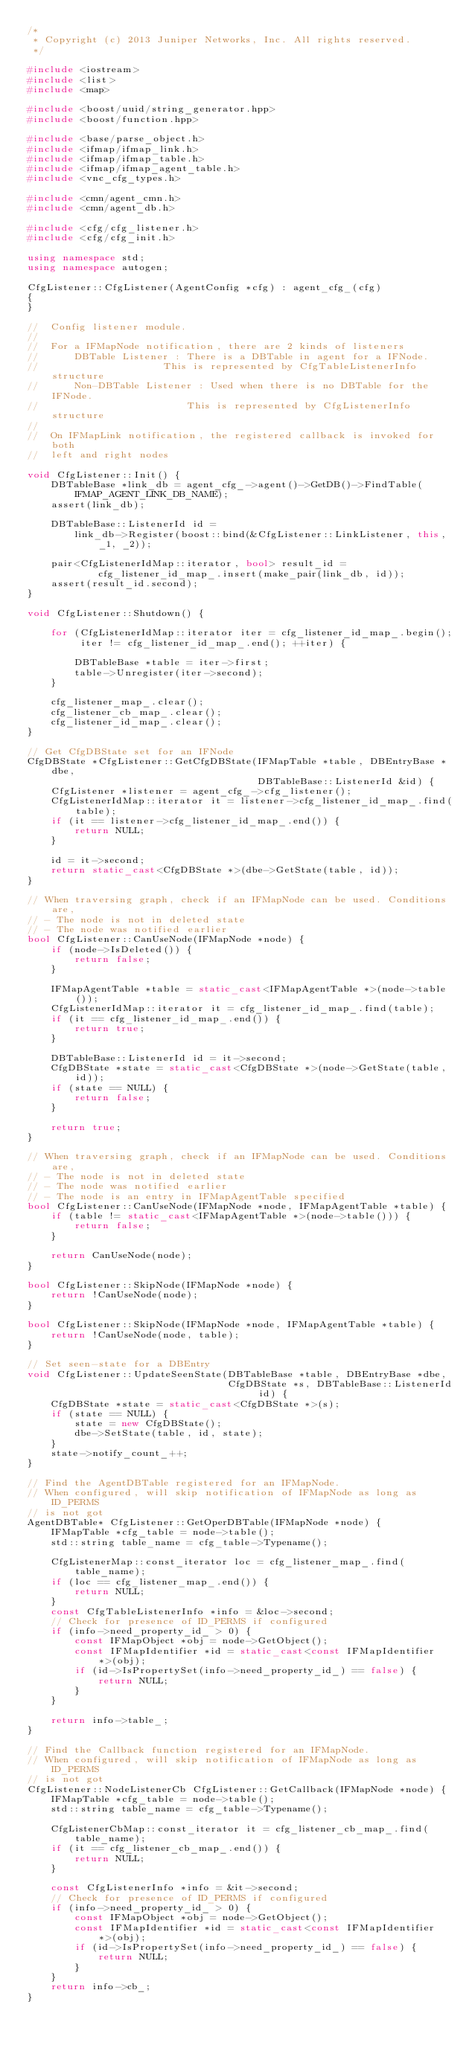Convert code to text. <code><loc_0><loc_0><loc_500><loc_500><_C++_>/*
 * Copyright (c) 2013 Juniper Networks, Inc. All rights reserved.
 */

#include <iostream>
#include <list>
#include <map>

#include <boost/uuid/string_generator.hpp>
#include <boost/function.hpp>

#include <base/parse_object.h>
#include <ifmap/ifmap_link.h>
#include <ifmap/ifmap_table.h>
#include <ifmap/ifmap_agent_table.h>
#include <vnc_cfg_types.h>

#include <cmn/agent_cmn.h>
#include <cmn/agent_db.h>

#include <cfg/cfg_listener.h>
#include <cfg/cfg_init.h>

using namespace std;
using namespace autogen;

CfgListener::CfgListener(AgentConfig *cfg) : agent_cfg_(cfg) 
{ 
}

//  Config listener module. 
//
//  For a IFMapNode notification, there are 2 kinds of listeners
//      DBTable Listener : There is a DBTable in agent for a IFNode. 
//                     This is represented by CfgTableListenerInfo structure
//      Non-DBTable Listener : Used when there is no DBTable for the IFNode.
//                         This is represented by CfgListenerInfo structure
//
//  On IFMapLink notification, the registered callback is invoked for both
//  left and right nodes

void CfgListener::Init() {
    DBTableBase *link_db = agent_cfg_->agent()->GetDB()->FindTable(IFMAP_AGENT_LINK_DB_NAME);
    assert(link_db);

    DBTableBase::ListenerId id = 
        link_db->Register(boost::bind(&CfgListener::LinkListener, this, _1, _2));

    pair<CfgListenerIdMap::iterator, bool> result_id =
            cfg_listener_id_map_.insert(make_pair(link_db, id));
    assert(result_id.second);
}

void CfgListener::Shutdown() {

    for (CfgListenerIdMap::iterator iter = cfg_listener_id_map_.begin();
         iter != cfg_listener_id_map_.end(); ++iter) {

        DBTableBase *table = iter->first;
        table->Unregister(iter->second);
    }

    cfg_listener_map_.clear();
    cfg_listener_cb_map_.clear();
    cfg_listener_id_map_.clear();
}

// Get CfgDBState set for an IFNode
CfgDBState *CfgListener::GetCfgDBState(IFMapTable *table, DBEntryBase *dbe,
                                       DBTableBase::ListenerId &id) {
    CfgListener *listener = agent_cfg_->cfg_listener();
    CfgListenerIdMap::iterator it = listener->cfg_listener_id_map_.find(table);
    if (it == listener->cfg_listener_id_map_.end()) {
        return NULL;
    }

    id = it->second;
    return static_cast<CfgDBState *>(dbe->GetState(table, id));
}

// When traversing graph, check if an IFMapNode can be used. Conditions are,
// - The node is not in deleted state
// - The node was notified earlier
bool CfgListener::CanUseNode(IFMapNode *node) {
    if (node->IsDeleted()) {
        return false;
    }

    IFMapAgentTable *table = static_cast<IFMapAgentTable *>(node->table());
    CfgListenerIdMap::iterator it = cfg_listener_id_map_.find(table);
    if (it == cfg_listener_id_map_.end()) {
        return true;
    }

    DBTableBase::ListenerId id = it->second;
    CfgDBState *state = static_cast<CfgDBState *>(node->GetState(table, id));
    if (state == NULL) {
        return false;
    }

    return true;
}

// When traversing graph, check if an IFMapNode can be used. Conditions are,
// - The node is not in deleted state
// - The node was notified earlier
// - The node is an entry in IFMapAgentTable specified
bool CfgListener::CanUseNode(IFMapNode *node, IFMapAgentTable *table) {
    if (table != static_cast<IFMapAgentTable *>(node->table())) {
        return false;
    }

    return CanUseNode(node);
}

bool CfgListener::SkipNode(IFMapNode *node) {
    return !CanUseNode(node);
}

bool CfgListener::SkipNode(IFMapNode *node, IFMapAgentTable *table) {
    return !CanUseNode(node, table);
}

// Set seen-state for a DBEntry
void CfgListener::UpdateSeenState(DBTableBase *table, DBEntryBase *dbe,
                                  CfgDBState *s, DBTableBase::ListenerId id) {
    CfgDBState *state = static_cast<CfgDBState *>(s);
    if (state == NULL) {
        state = new CfgDBState();
        dbe->SetState(table, id, state);
    }
    state->notify_count_++;
}

// Find the AgentDBTable registered for an IFMapNode.
// When configured, will skip notification of IFMapNode as long as ID_PERMS
// is not got
AgentDBTable* CfgListener::GetOperDBTable(IFMapNode *node) {
    IFMapTable *cfg_table = node->table();
    std::string table_name = cfg_table->Typename();

    CfgListenerMap::const_iterator loc = cfg_listener_map_.find(table_name);
    if (loc == cfg_listener_map_.end()) {
        return NULL;
    }
    const CfgTableListenerInfo *info = &loc->second;
    // Check for presence of ID_PERMS if configured
    if (info->need_property_id_ > 0) {
        const IFMapObject *obj = node->GetObject();
        const IFMapIdentifier *id = static_cast<const IFMapIdentifier *>(obj);
        if (id->IsPropertySet(info->need_property_id_) == false) {
            return NULL;
        }
    }

    return info->table_;
}

// Find the Callback function registered for an IFMapNode.
// When configured, will skip notification of IFMapNode as long as ID_PERMS
// is not got
CfgListener::NodeListenerCb CfgListener::GetCallback(IFMapNode *node) {
    IFMapTable *cfg_table = node->table();
    std::string table_name = cfg_table->Typename();

    CfgListenerCbMap::const_iterator it = cfg_listener_cb_map_.find(table_name);
    if (it == cfg_listener_cb_map_.end()) {
        return NULL;
    }

    const CfgListenerInfo *info = &it->second;
    // Check for presence of ID_PERMS if configured
    if (info->need_property_id_ > 0) {
        const IFMapObject *obj = node->GetObject();
        const IFMapIdentifier *id = static_cast<const IFMapIdentifier *>(obj);
        if (id->IsPropertySet(info->need_property_id_) == false) {
            return NULL;
        }
    }
    return info->cb_;
}
</code> 